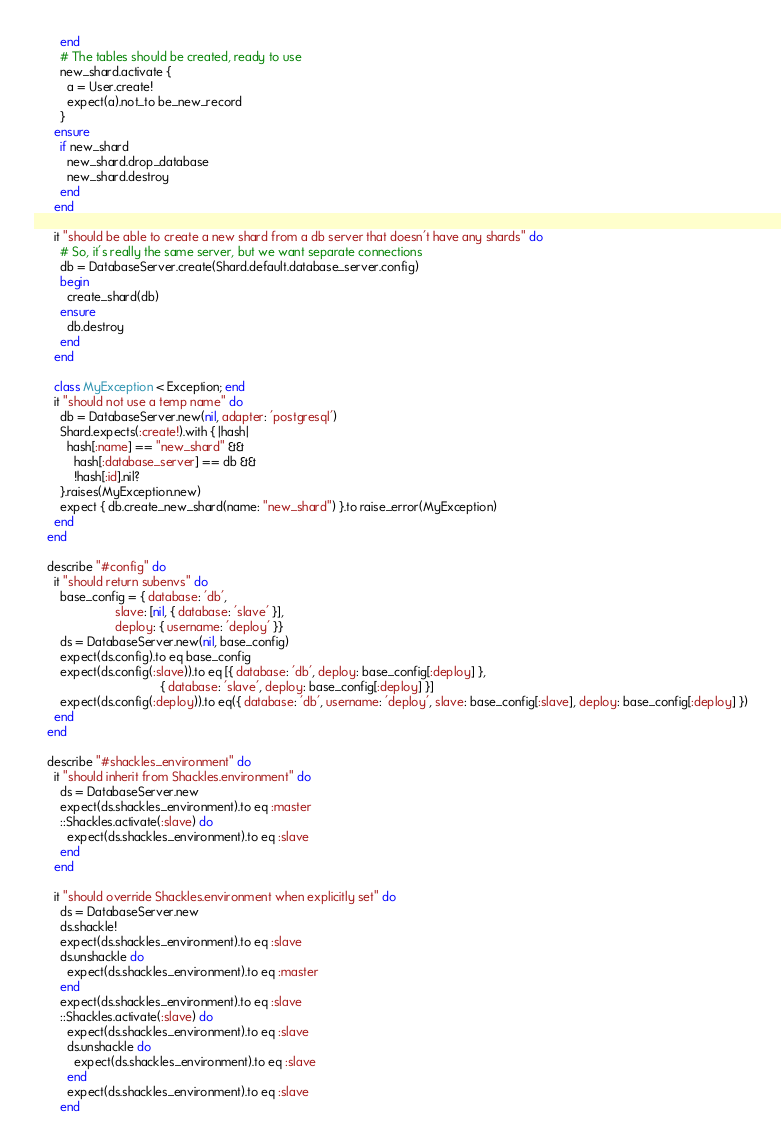Convert code to text. <code><loc_0><loc_0><loc_500><loc_500><_Ruby_>        end
        # The tables should be created, ready to use
        new_shard.activate {
          a = User.create!
          expect(a).not_to be_new_record
        }
      ensure
        if new_shard
          new_shard.drop_database
          new_shard.destroy
        end
      end

      it "should be able to create a new shard from a db server that doesn't have any shards" do
        # So, it's really the same server, but we want separate connections
        db = DatabaseServer.create(Shard.default.database_server.config)
        begin
          create_shard(db)
        ensure
          db.destroy
        end
      end

      class MyException < Exception; end
      it "should not use a temp name" do
        db = DatabaseServer.new(nil, adapter: 'postgresql')
        Shard.expects(:create!).with { |hash|
          hash[:name] == "new_shard" &&
            hash[:database_server] == db &&
            !hash[:id].nil?
        }.raises(MyException.new)
        expect { db.create_new_shard(name: "new_shard") }.to raise_error(MyException)
      end
    end

    describe "#config" do
      it "should return subenvs" do
        base_config = { database: 'db',
                        slave: [nil, { database: 'slave' }],
                        deploy: { username: 'deploy' }}
        ds = DatabaseServer.new(nil, base_config)
        expect(ds.config).to eq base_config
        expect(ds.config(:slave)).to eq [{ database: 'db', deploy: base_config[:deploy] },
                                     { database: 'slave', deploy: base_config[:deploy] }]
        expect(ds.config(:deploy)).to eq({ database: 'db', username: 'deploy', slave: base_config[:slave], deploy: base_config[:deploy] })
      end
    end

    describe "#shackles_environment" do
      it "should inherit from Shackles.environment" do
        ds = DatabaseServer.new
        expect(ds.shackles_environment).to eq :master
        ::Shackles.activate(:slave) do
          expect(ds.shackles_environment).to eq :slave
        end
      end

      it "should override Shackles.environment when explicitly set" do
        ds = DatabaseServer.new
        ds.shackle!
        expect(ds.shackles_environment).to eq :slave
        ds.unshackle do
          expect(ds.shackles_environment).to eq :master
        end
        expect(ds.shackles_environment).to eq :slave
        ::Shackles.activate(:slave) do
          expect(ds.shackles_environment).to eq :slave
          ds.unshackle do
            expect(ds.shackles_environment).to eq :slave
          end
          expect(ds.shackles_environment).to eq :slave
        end</code> 